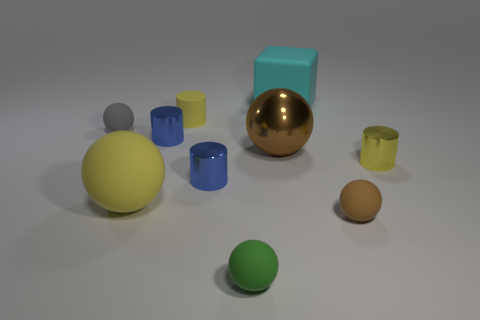What material is the small brown thing?
Your answer should be compact. Rubber. Is the size of the cyan object the same as the green object?
Give a very brief answer. No. What number of balls are either yellow rubber objects or large green rubber things?
Offer a terse response. 1. The matte cube on the right side of the big sphere in front of the large metallic ball is what color?
Offer a terse response. Cyan. Are there fewer small balls that are left of the small gray object than yellow matte things that are on the right side of the metallic sphere?
Make the answer very short. No. Does the rubber block have the same size as the brown thing that is on the left side of the large rubber cube?
Provide a short and direct response. Yes. What shape is the matte object that is in front of the yellow rubber ball and on the right side of the brown metallic sphere?
Give a very brief answer. Sphere. There is a cyan block that is made of the same material as the gray object; what is its size?
Your response must be concise. Large. There is a small matte ball on the right side of the tiny green matte object; how many small yellow things are on the right side of it?
Your answer should be compact. 1. Does the yellow sphere that is on the left side of the small yellow shiny object have the same material as the tiny brown sphere?
Offer a terse response. Yes. 